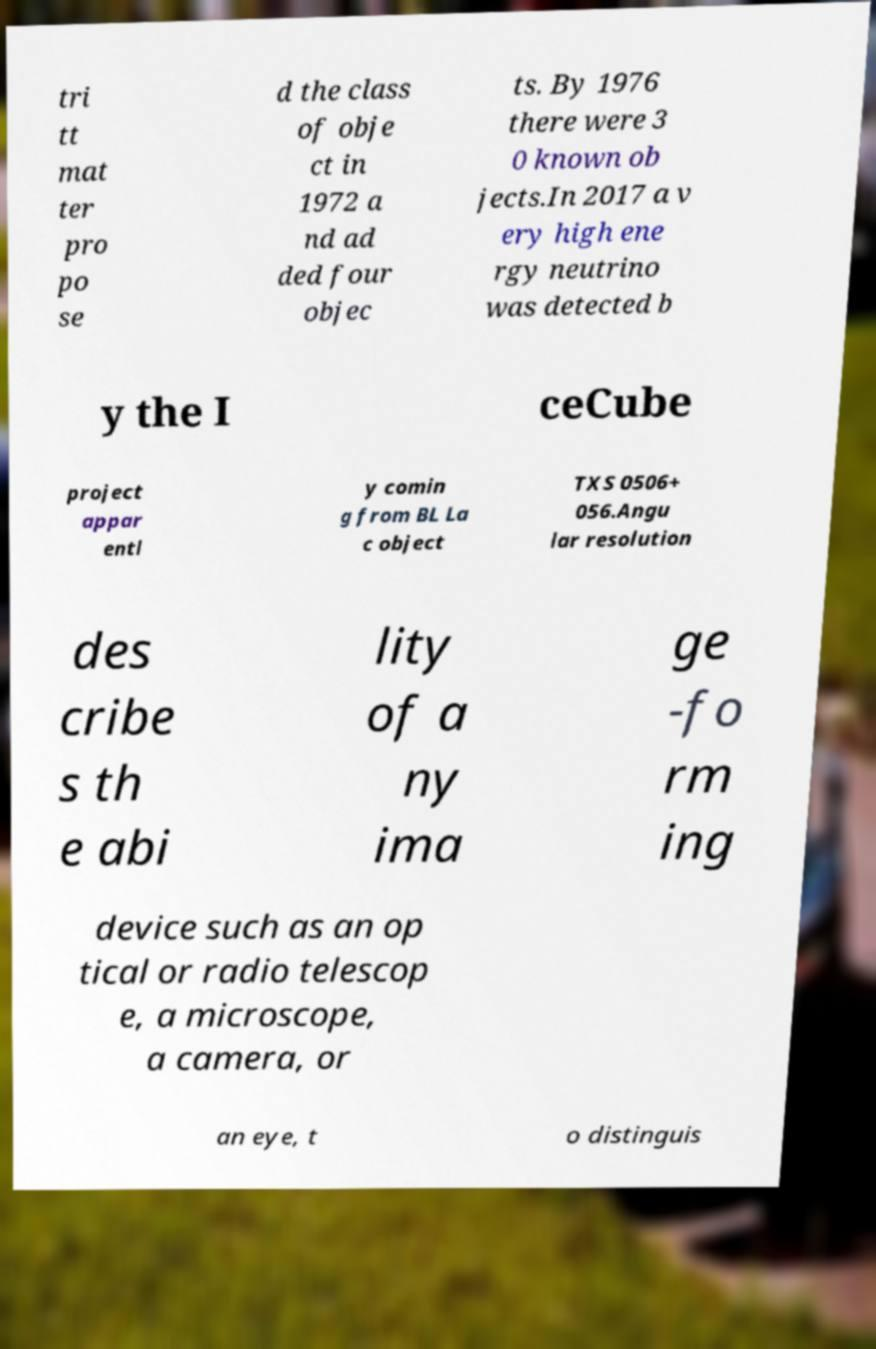Can you accurately transcribe the text from the provided image for me? tri tt mat ter pro po se d the class of obje ct in 1972 a nd ad ded four objec ts. By 1976 there were 3 0 known ob jects.In 2017 a v ery high ene rgy neutrino was detected b y the I ceCube project appar entl y comin g from BL La c object TXS 0506+ 056.Angu lar resolution des cribe s th e abi lity of a ny ima ge -fo rm ing device such as an op tical or radio telescop e, a microscope, a camera, or an eye, t o distinguis 